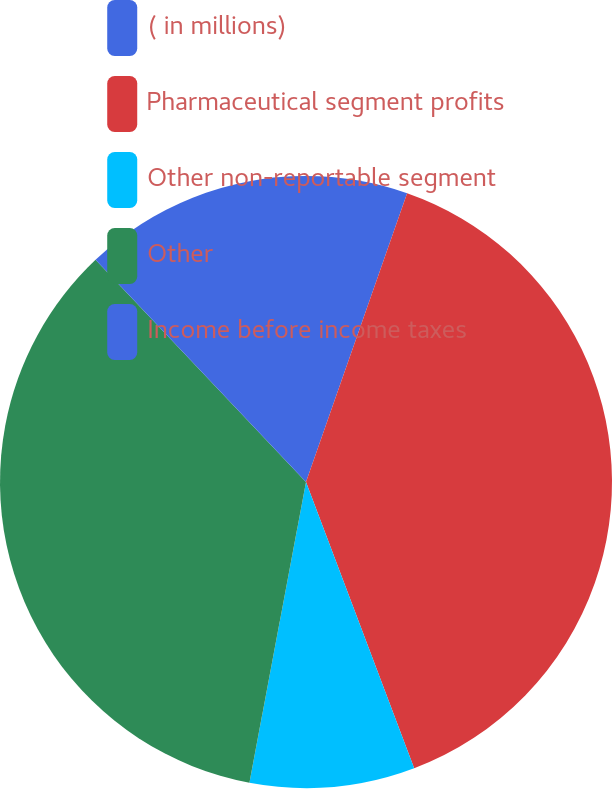<chart> <loc_0><loc_0><loc_500><loc_500><pie_chart><fcel>( in millions)<fcel>Pharmaceutical segment profits<fcel>Other non-reportable segment<fcel>Other<fcel>Income before income taxes<nl><fcel>5.36%<fcel>38.89%<fcel>8.71%<fcel>34.97%<fcel>12.07%<nl></chart> 